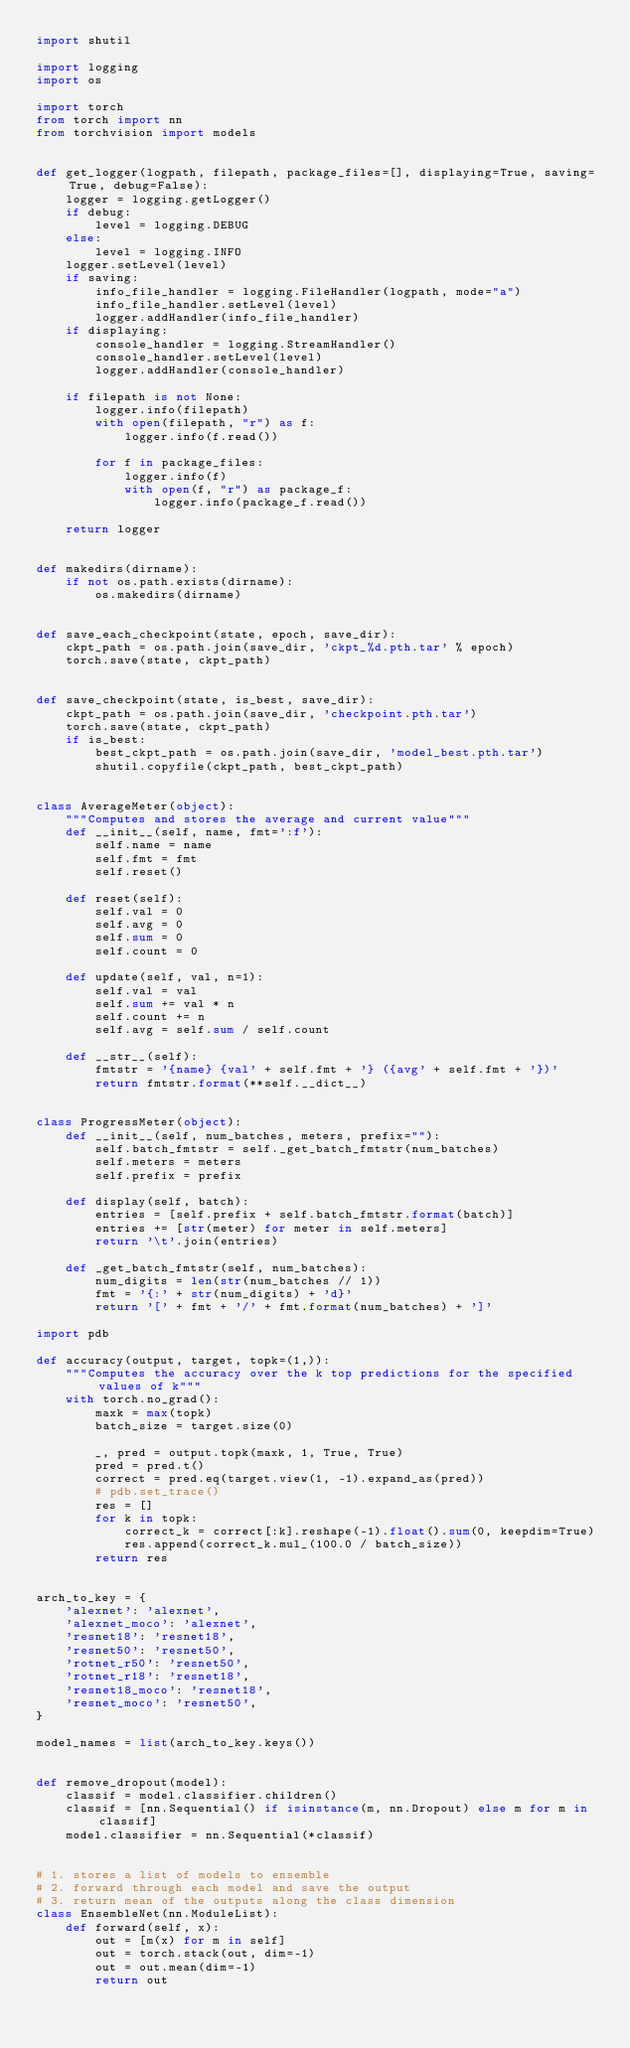<code> <loc_0><loc_0><loc_500><loc_500><_Python_>import shutil

import logging
import os

import torch
from torch import nn
from torchvision import models


def get_logger(logpath, filepath, package_files=[], displaying=True, saving=True, debug=False):
    logger = logging.getLogger()
    if debug:
        level = logging.DEBUG
    else:
        level = logging.INFO
    logger.setLevel(level)
    if saving:
        info_file_handler = logging.FileHandler(logpath, mode="a")
        info_file_handler.setLevel(level)
        logger.addHandler(info_file_handler)
    if displaying:
        console_handler = logging.StreamHandler()
        console_handler.setLevel(level)
        logger.addHandler(console_handler)

    if filepath is not None:
        logger.info(filepath)
        with open(filepath, "r") as f:
            logger.info(f.read())

        for f in package_files:
            logger.info(f)
            with open(f, "r") as package_f:
                logger.info(package_f.read())

    return logger


def makedirs(dirname):
    if not os.path.exists(dirname):
        os.makedirs(dirname)


def save_each_checkpoint(state, epoch, save_dir):
    ckpt_path = os.path.join(save_dir, 'ckpt_%d.pth.tar' % epoch)
    torch.save(state, ckpt_path)


def save_checkpoint(state, is_best, save_dir):
    ckpt_path = os.path.join(save_dir, 'checkpoint.pth.tar')
    torch.save(state, ckpt_path)
    if is_best:
        best_ckpt_path = os.path.join(save_dir, 'model_best.pth.tar')
        shutil.copyfile(ckpt_path, best_ckpt_path)


class AverageMeter(object):
    """Computes and stores the average and current value"""
    def __init__(self, name, fmt=':f'):
        self.name = name
        self.fmt = fmt
        self.reset()

    def reset(self):
        self.val = 0
        self.avg = 0
        self.sum = 0
        self.count = 0

    def update(self, val, n=1):
        self.val = val
        self.sum += val * n
        self.count += n
        self.avg = self.sum / self.count

    def __str__(self):
        fmtstr = '{name} {val' + self.fmt + '} ({avg' + self.fmt + '})'
        return fmtstr.format(**self.__dict__)


class ProgressMeter(object):
    def __init__(self, num_batches, meters, prefix=""):
        self.batch_fmtstr = self._get_batch_fmtstr(num_batches)
        self.meters = meters
        self.prefix = prefix

    def display(self, batch):
        entries = [self.prefix + self.batch_fmtstr.format(batch)]
        entries += [str(meter) for meter in self.meters]
        return '\t'.join(entries)

    def _get_batch_fmtstr(self, num_batches):
        num_digits = len(str(num_batches // 1))
        fmt = '{:' + str(num_digits) + 'd}'
        return '[' + fmt + '/' + fmt.format(num_batches) + ']'

import pdb

def accuracy(output, target, topk=(1,)):
    """Computes the accuracy over the k top predictions for the specified values of k"""
    with torch.no_grad():
        maxk = max(topk)
        batch_size = target.size(0)

        _, pred = output.topk(maxk, 1, True, True)
        pred = pred.t()
        correct = pred.eq(target.view(1, -1).expand_as(pred))
        # pdb.set_trace()
        res = []
        for k in topk:
            correct_k = correct[:k].reshape(-1).float().sum(0, keepdim=True)
            res.append(correct_k.mul_(100.0 / batch_size))
        return res


arch_to_key = {
    'alexnet': 'alexnet',
    'alexnet_moco': 'alexnet',
    'resnet18': 'resnet18',
    'resnet50': 'resnet50',
    'rotnet_r50': 'resnet50',
    'rotnet_r18': 'resnet18',
    'resnet18_moco': 'resnet18',
    'resnet_moco': 'resnet50',
}

model_names = list(arch_to_key.keys())


def remove_dropout(model):
    classif = model.classifier.children()
    classif = [nn.Sequential() if isinstance(m, nn.Dropout) else m for m in classif]
    model.classifier = nn.Sequential(*classif)


# 1. stores a list of models to ensemble
# 2. forward through each model and save the output
# 3. return mean of the outputs along the class dimension
class EnsembleNet(nn.ModuleList):
    def forward(self, x):
        out = [m(x) for m in self]
        out = torch.stack(out, dim=-1)
        out = out.mean(dim=-1)
        return out
</code> 